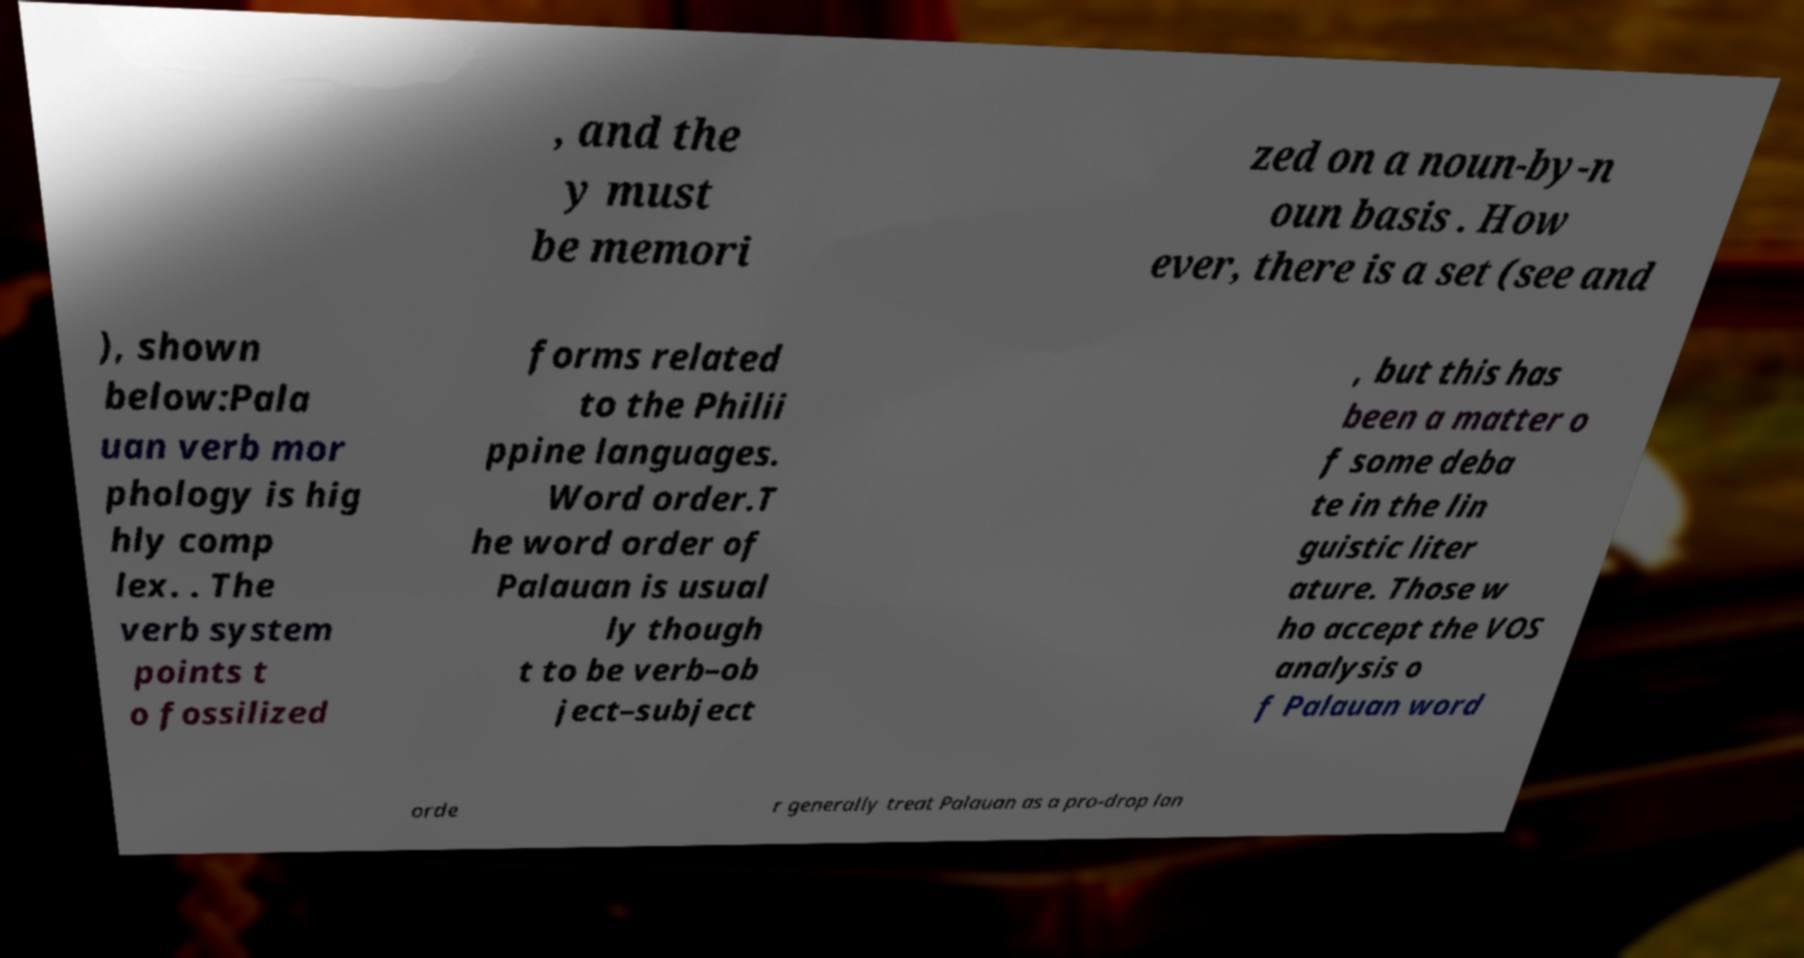I need the written content from this picture converted into text. Can you do that? , and the y must be memori zed on a noun-by-n oun basis . How ever, there is a set (see and ), shown below:Pala uan verb mor phology is hig hly comp lex. . The verb system points t o fossilized forms related to the Philii ppine languages. Word order.T he word order of Palauan is usual ly though t to be verb–ob ject–subject , but this has been a matter o f some deba te in the lin guistic liter ature. Those w ho accept the VOS analysis o f Palauan word orde r generally treat Palauan as a pro-drop lan 